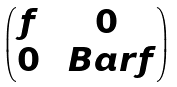Convert formula to latex. <formula><loc_0><loc_0><loc_500><loc_500>\begin{pmatrix} f & 0 \\ 0 & \ B a r { f } \end{pmatrix}</formula> 